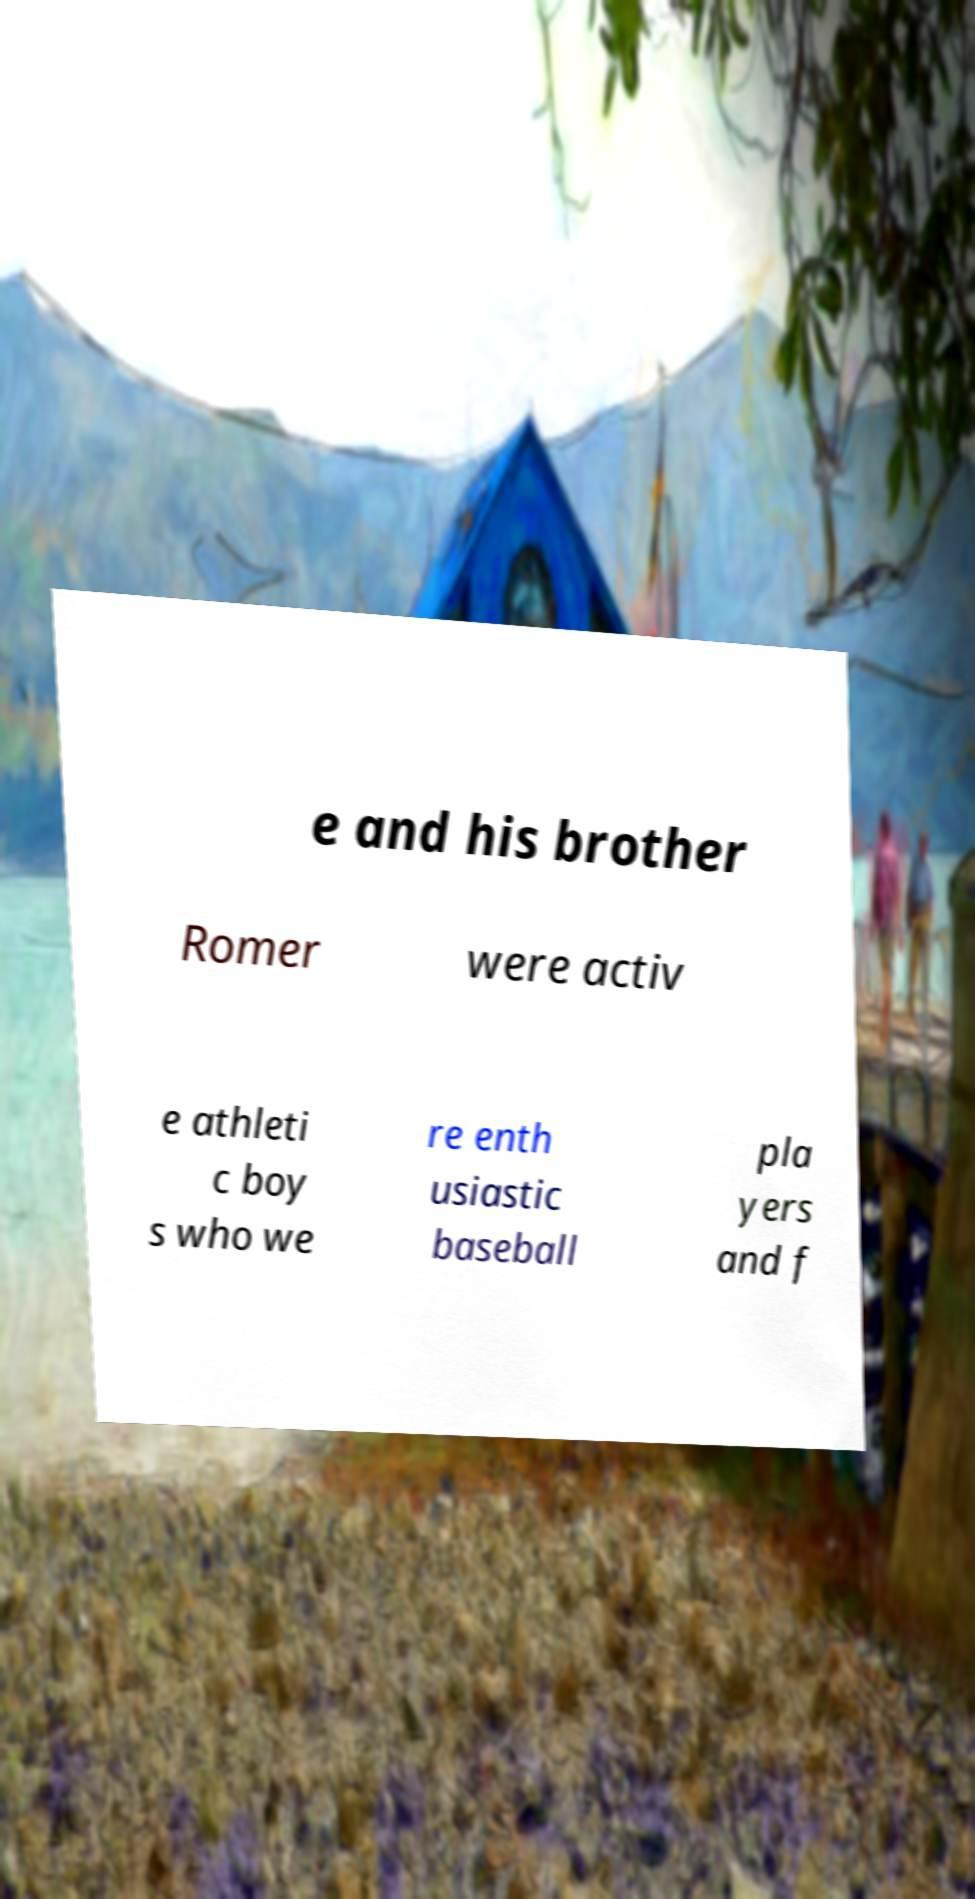Could you assist in decoding the text presented in this image and type it out clearly? e and his brother Romer were activ e athleti c boy s who we re enth usiastic baseball pla yers and f 